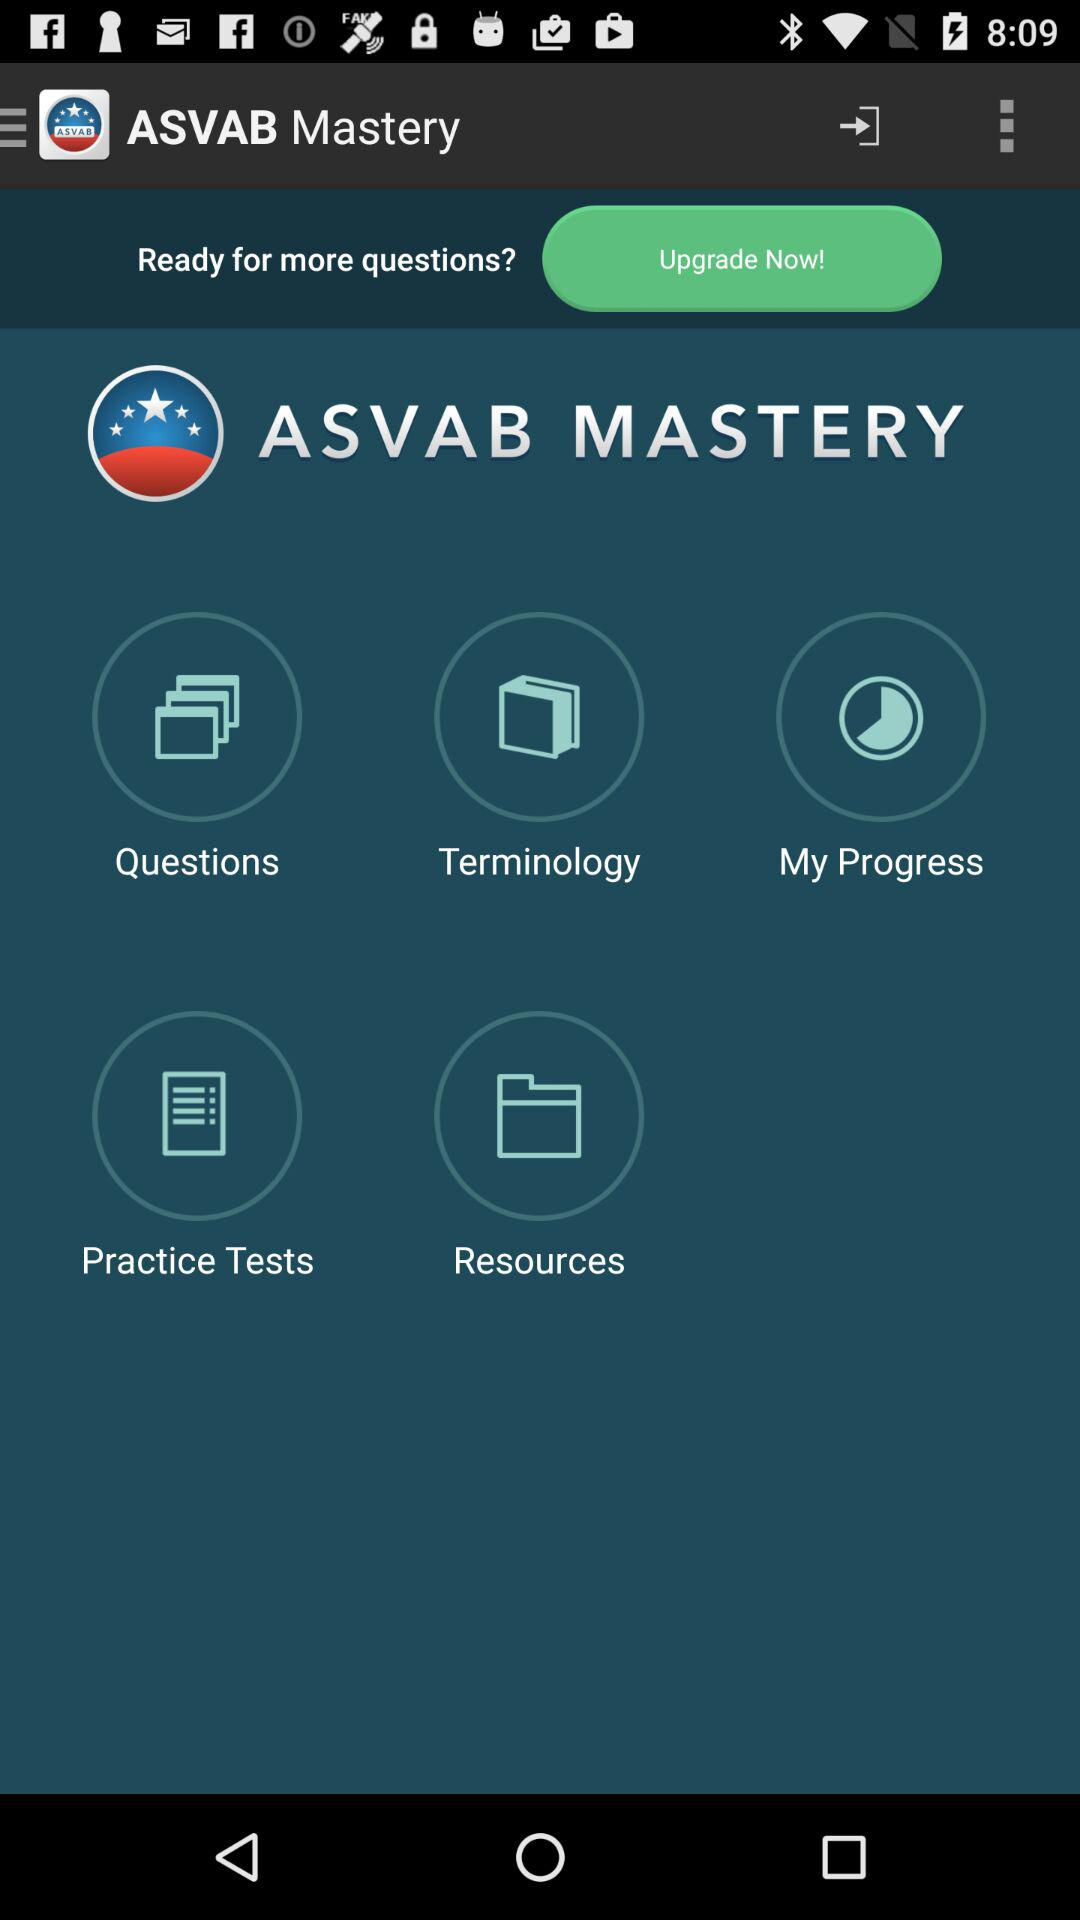What is the name of the application? The name of the application is "ASVAB Mastery". 